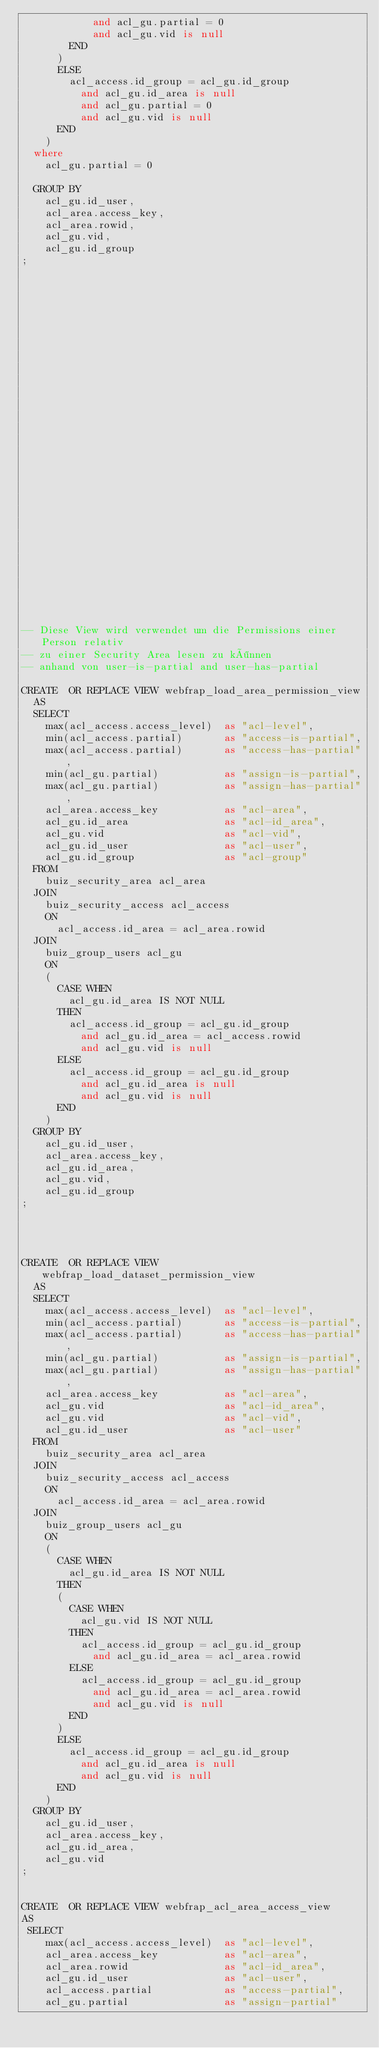<code> <loc_0><loc_0><loc_500><loc_500><_SQL_>            and acl_gu.partial = 0
            and acl_gu.vid is null
        END
      )
      ELSE
        acl_access.id_group = acl_gu.id_group
          and acl_gu.id_area is null
          and acl_gu.partial = 0
          and acl_gu.vid is null
      END
    )
  where
    acl_gu.partial = 0
    
  GROUP BY
    acl_gu.id_user,
    acl_area.access_key,
    acl_area.rowid,                 
    acl_gu.vid,           
    acl_gu.id_group
;






























-- Diese View wird verwendet um die Permissions einer Person relativ
-- zu einer Security Area lesen zu können
-- anhand von user-is-partial and user-has-partial  

CREATE  OR REPLACE VIEW webfrap_load_area_permission_view
  AS 
  SELECT
    max(acl_access.access_level)  as "acl-level",
    min(acl_access.partial)       as "access-is-partial",
    max(acl_access.partial)       as "access-has-partial",
    min(acl_gu.partial)           as "assign-is-partial",
    max(acl_gu.partial)           as "assign-has-partial",
    acl_area.access_key           as "acl-area",
    acl_gu.id_area                as "acl-id_area",
    acl_gu.vid                    as "acl-vid",
    acl_gu.id_user                as "acl-user",
    acl_gu.id_group               as "acl-group"
  FROM
    buiz_security_area acl_area
  JOIN
    buiz_security_access acl_access
    ON
      acl_access.id_area = acl_area.rowid
  JOIN
    buiz_group_users acl_gu
    ON
    (
      CASE WHEN
        acl_gu.id_area IS NOT NULL
      THEN
        acl_access.id_group = acl_gu.id_group
          and acl_gu.id_area = acl_access.rowid
          and acl_gu.vid is null
      ELSE
        acl_access.id_group = acl_gu.id_group
          and acl_gu.id_area is null
          and acl_gu.vid is null
      END
    )
  GROUP BY
    acl_gu.id_user,
    acl_area.access_key,
    acl_gu.id_area,              
    acl_gu.vid,              
    acl_gu.id_group
;




CREATE  OR REPLACE VIEW webfrap_load_dataset_permission_view
  AS 
  SELECT
    max(acl_access.access_level)  as "acl-level",
    min(acl_access.partial)       as "access-is-partial",
    max(acl_access.partial)       as "access-has-partial",
    min(acl_gu.partial)           as "assign-is-partial",
    max(acl_gu.partial)           as "assign-has-partial",
    acl_area.access_key           as "acl-area",
    acl_gu.vid                    as "acl-id_area",
    acl_gu.vid                    as "acl-vid",
    acl_gu.id_user                as "acl-user"
  FROM
    buiz_security_area acl_area
  JOIN
    buiz_security_access acl_access
    ON
      acl_access.id_area = acl_area.rowid
  JOIN
    buiz_group_users acl_gu
    ON
    (
      CASE WHEN
        acl_gu.id_area IS NOT NULL
      THEN
      (
        CASE WHEN
          acl_gu.vid IS NOT NULL
        THEN
          acl_access.id_group = acl_gu.id_group
            and acl_gu.id_area = acl_area.rowid
        ELSE
          acl_access.id_group = acl_gu.id_group
            and acl_gu.id_area = acl_area.rowid
            and acl_gu.vid is null
        END
      )
      ELSE
        acl_access.id_group = acl_gu.id_group
          and acl_gu.id_area is null
          and acl_gu.vid is null
      END
    )
  GROUP BY
    acl_gu.id_user,
    acl_area.access_key,
    acl_gu.id_area,              
    acl_gu.vid
;


CREATE  OR REPLACE VIEW webfrap_acl_area_access_view
AS
 SELECT
    max(acl_access.access_level)  as "acl-level",
    acl_area.access_key           as "acl-area",
    acl_area.rowid                as "acl-id_area",
    acl_gu.id_user                as "acl-user",
    acl_access.partial            as "access-partial",
    acl_gu.partial                as "assign-partial"</code> 